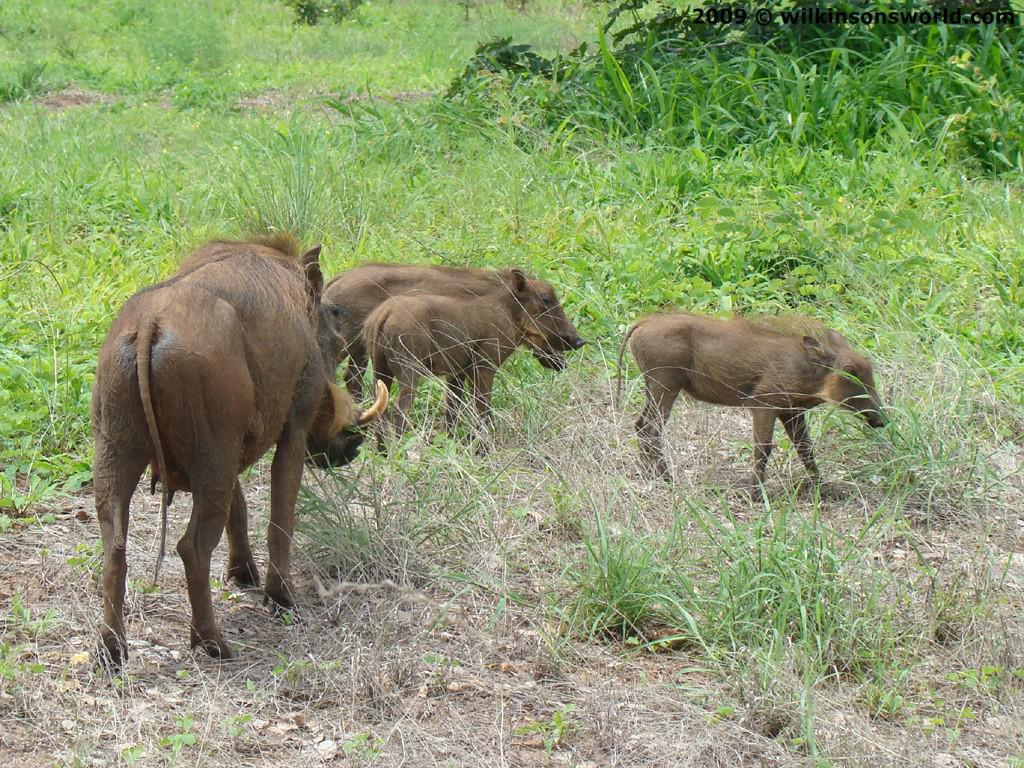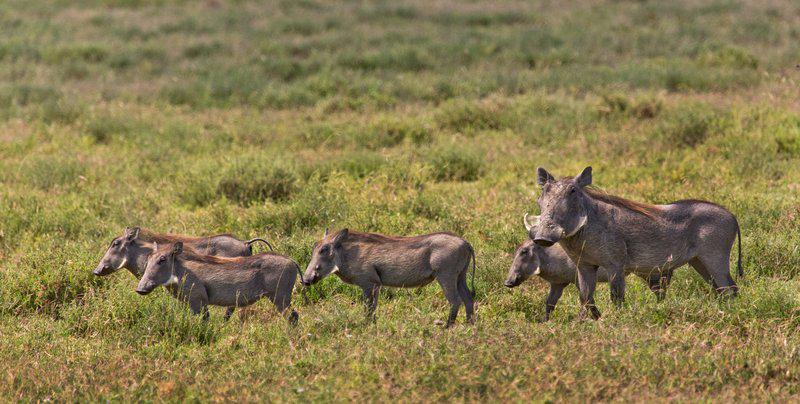The first image is the image on the left, the second image is the image on the right. For the images displayed, is the sentence "There are 4 warthogs in the left image." factually correct? Answer yes or no. Yes. The first image is the image on the left, the second image is the image on the right. For the images shown, is this caption "one of the images shows a group of hogs standing and facing right." true? Answer yes or no. No. 